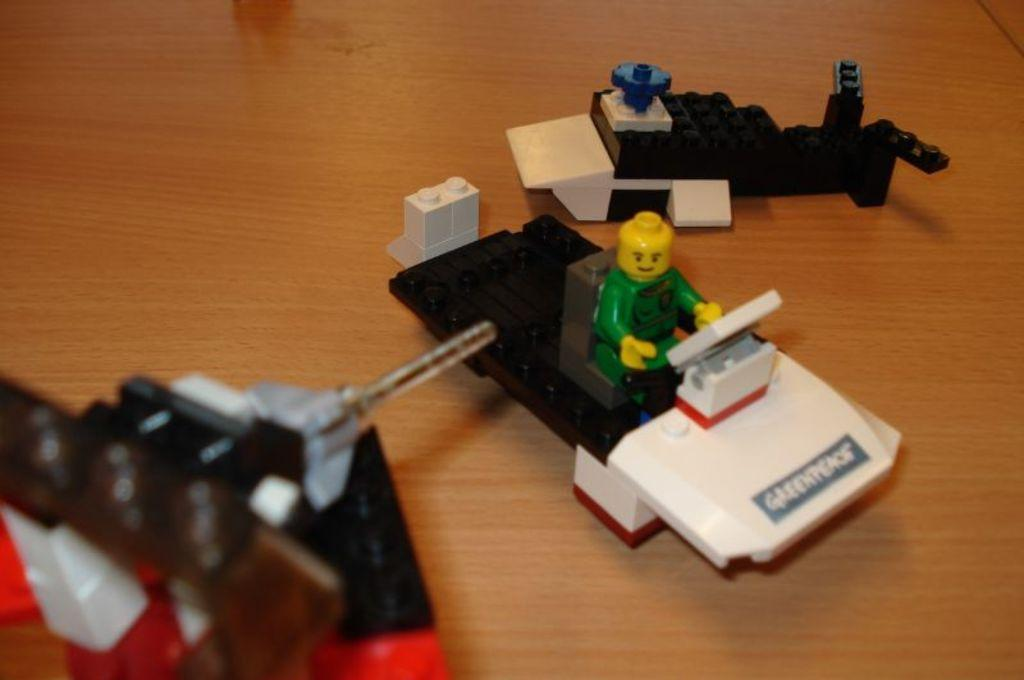What type of items can be seen in the image? There are toys and other objects in the image. What material is the surface that the toys and objects are placed on? The wooden surface is present in the image. What type of brush is being used to paint the level in the image? There is no brush or level present in the image; it only contains toys and other objects on a wooden surface. 